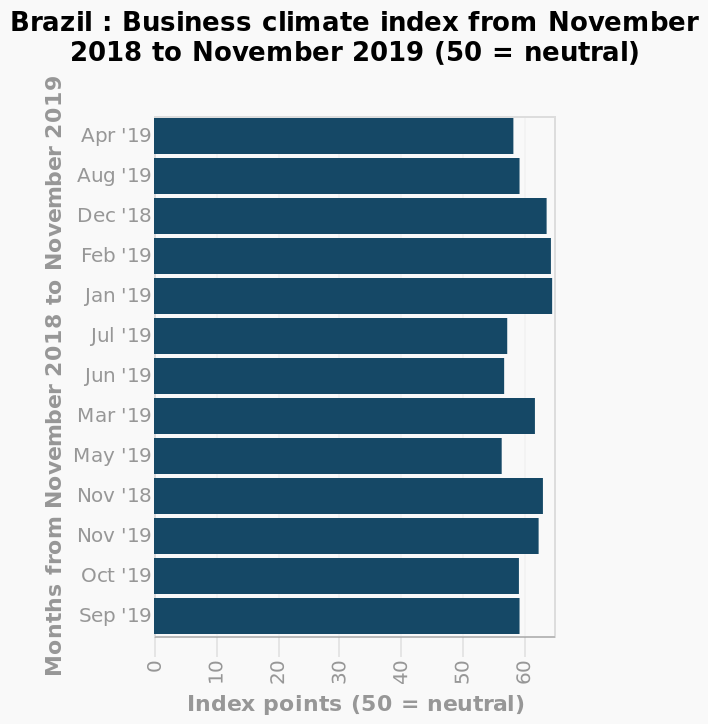<image>
Which month is closest to neutral on the y-axis?  The month closest to neutral on the y-axis is May 2019. 